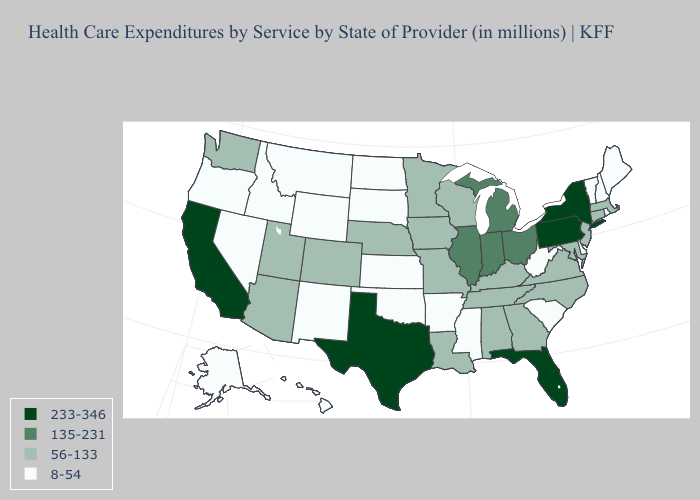Does the first symbol in the legend represent the smallest category?
Give a very brief answer. No. Does the map have missing data?
Quick response, please. No. Name the states that have a value in the range 8-54?
Keep it brief. Alaska, Arkansas, Delaware, Hawaii, Idaho, Kansas, Maine, Mississippi, Montana, Nevada, New Hampshire, New Mexico, North Dakota, Oklahoma, Oregon, Rhode Island, South Carolina, South Dakota, Vermont, West Virginia, Wyoming. Does California have the highest value in the West?
Write a very short answer. Yes. Among the states that border Illinois , which have the lowest value?
Short answer required. Iowa, Kentucky, Missouri, Wisconsin. Name the states that have a value in the range 56-133?
Answer briefly. Alabama, Arizona, Colorado, Connecticut, Georgia, Iowa, Kentucky, Louisiana, Maryland, Massachusetts, Minnesota, Missouri, Nebraska, New Jersey, North Carolina, Tennessee, Utah, Virginia, Washington, Wisconsin. What is the value of Maine?
Short answer required. 8-54. Does the map have missing data?
Concise answer only. No. Among the states that border Minnesota , which have the lowest value?
Quick response, please. North Dakota, South Dakota. What is the value of Alabama?
Be succinct. 56-133. What is the lowest value in the USA?
Quick response, please. 8-54. How many symbols are there in the legend?
Quick response, please. 4. Name the states that have a value in the range 233-346?
Be succinct. California, Florida, New York, Pennsylvania, Texas. Which states hav the highest value in the West?
Give a very brief answer. California. What is the value of South Carolina?
Short answer required. 8-54. 